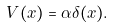<formula> <loc_0><loc_0><loc_500><loc_500>V ( x ) = \alpha \delta ( x ) .</formula> 